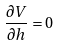<formula> <loc_0><loc_0><loc_500><loc_500>\frac { \partial V } { \partial h } = 0</formula> 